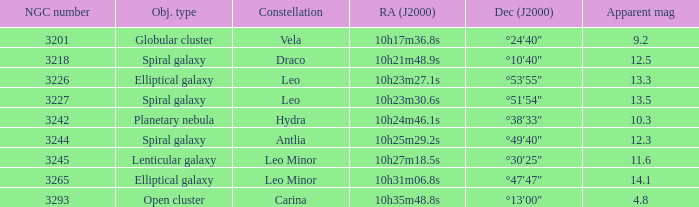What is the Apparent magnitude of a globular cluster? 9.2. 